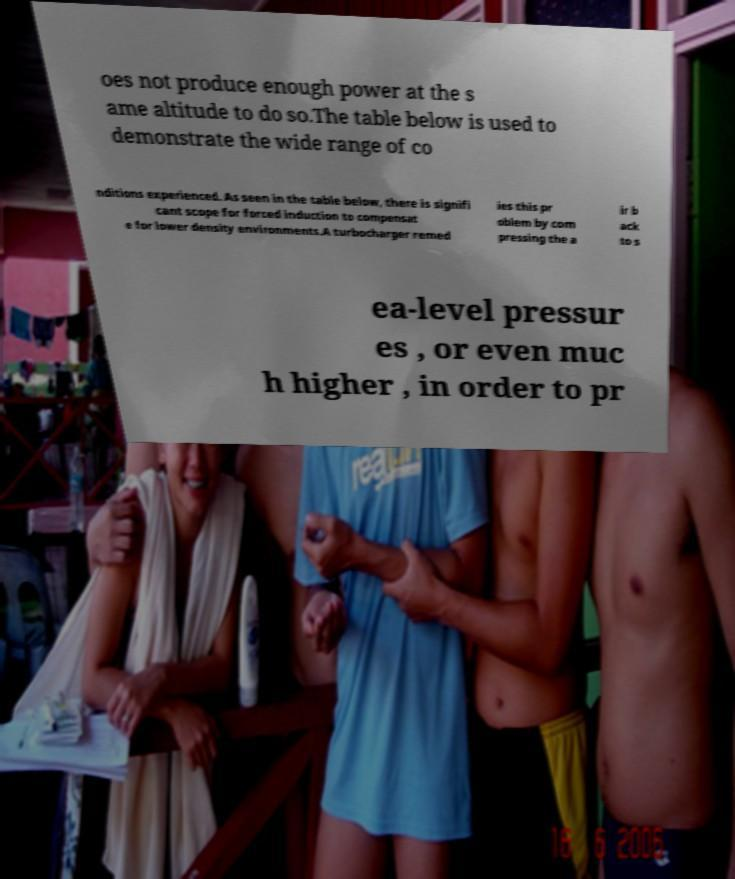For documentation purposes, I need the text within this image transcribed. Could you provide that? oes not produce enough power at the s ame altitude to do so.The table below is used to demonstrate the wide range of co nditions experienced. As seen in the table below, there is signifi cant scope for forced induction to compensat e for lower density environments.A turbocharger remed ies this pr oblem by com pressing the a ir b ack to s ea-level pressur es , or even muc h higher , in order to pr 